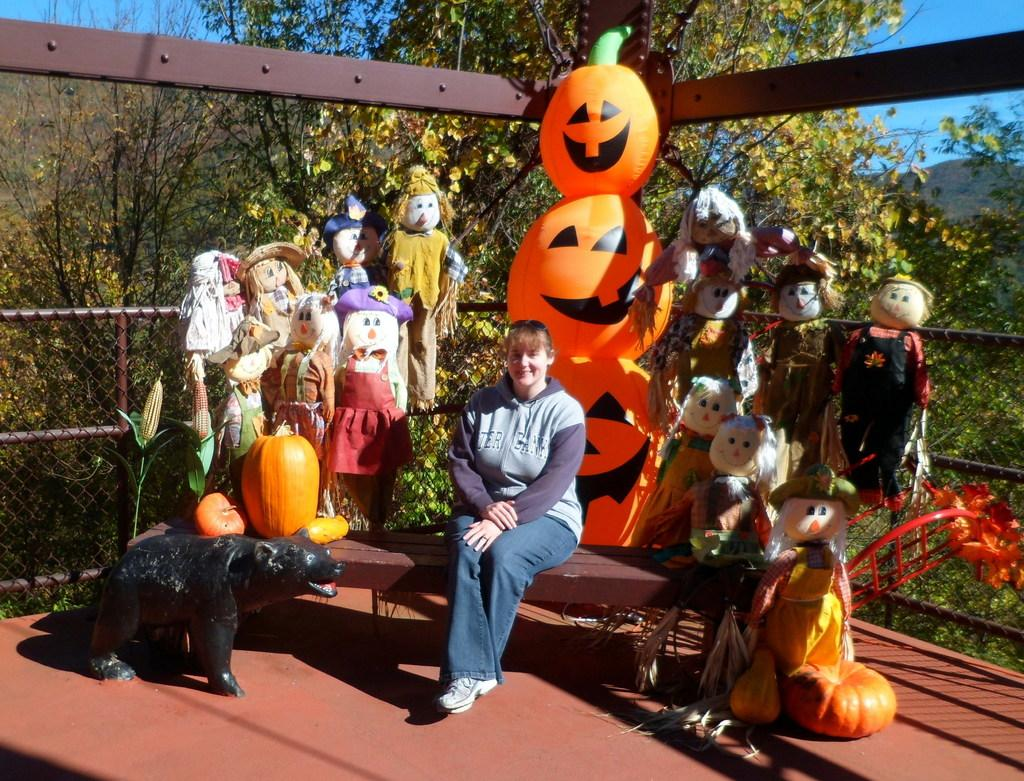What is the lady in the image doing? The lady is sitting on a bench in the image. What can be seen around the lady? There are many toys around the lady. What is visible in the background of the image? There are trees in the background of the image. What type of structure is present in the image? There is a fencing in the image. What language is the lady speaking in the image? There is no indication of the lady speaking in the image, so it cannot be determined what language she might be using. 